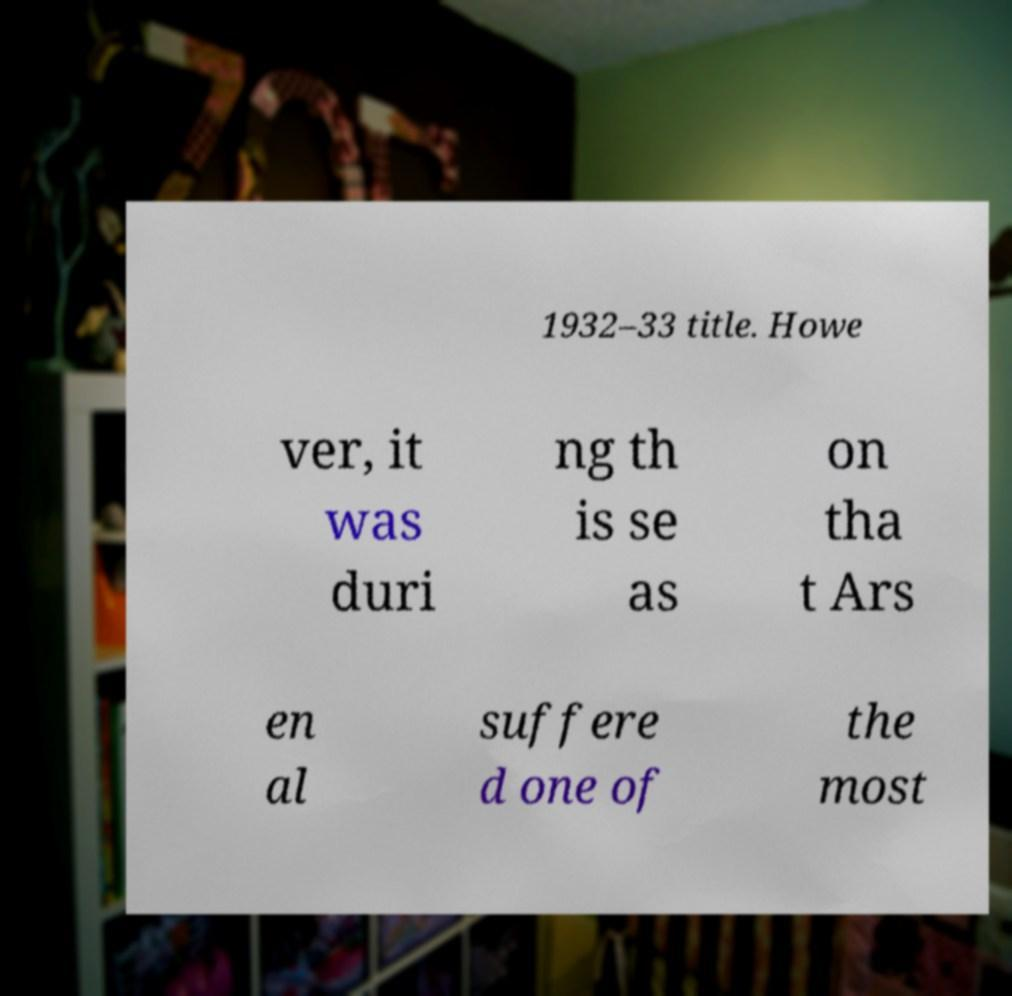Please read and relay the text visible in this image. What does it say? 1932–33 title. Howe ver, it was duri ng th is se as on tha t Ars en al suffere d one of the most 